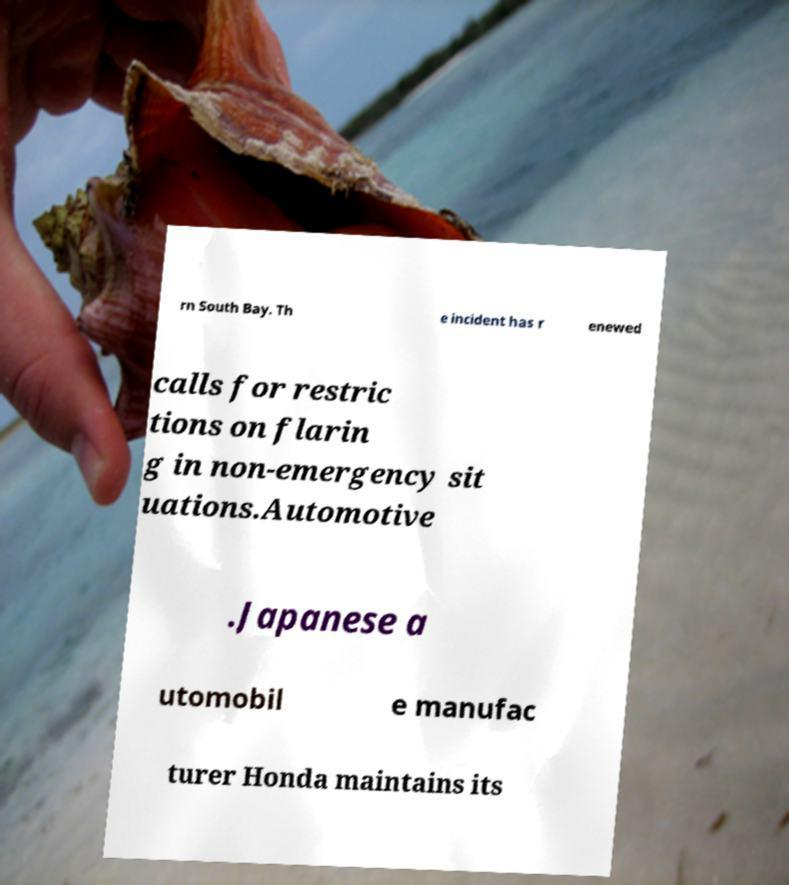Please read and relay the text visible in this image. What does it say? rn South Bay. Th e incident has r enewed calls for restric tions on flarin g in non-emergency sit uations.Automotive .Japanese a utomobil e manufac turer Honda maintains its 